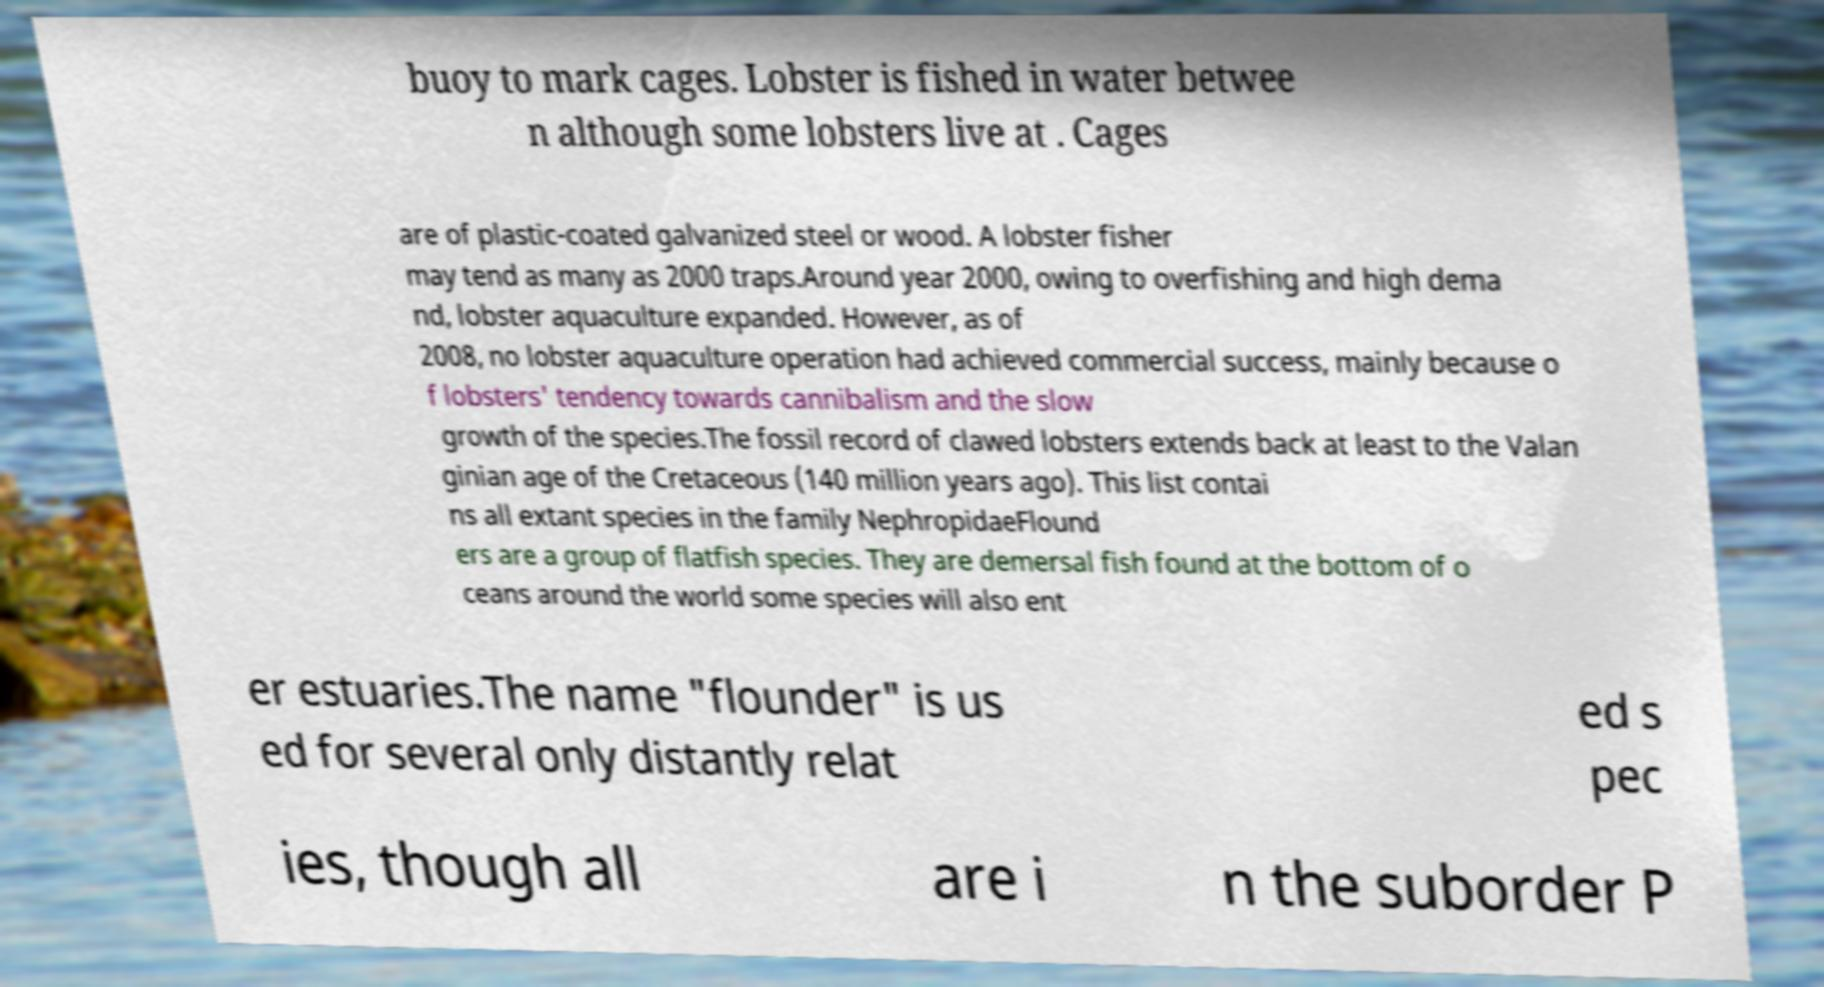I need the written content from this picture converted into text. Can you do that? buoy to mark cages. Lobster is fished in water betwee n although some lobsters live at . Cages are of plastic-coated galvanized steel or wood. A lobster fisher may tend as many as 2000 traps.Around year 2000, owing to overfishing and high dema nd, lobster aquaculture expanded. However, as of 2008, no lobster aquaculture operation had achieved commercial success, mainly because o f lobsters' tendency towards cannibalism and the slow growth of the species.The fossil record of clawed lobsters extends back at least to the Valan ginian age of the Cretaceous (140 million years ago). This list contai ns all extant species in the family NephropidaeFlound ers are a group of flatfish species. They are demersal fish found at the bottom of o ceans around the world some species will also ent er estuaries.The name "flounder" is us ed for several only distantly relat ed s pec ies, though all are i n the suborder P 